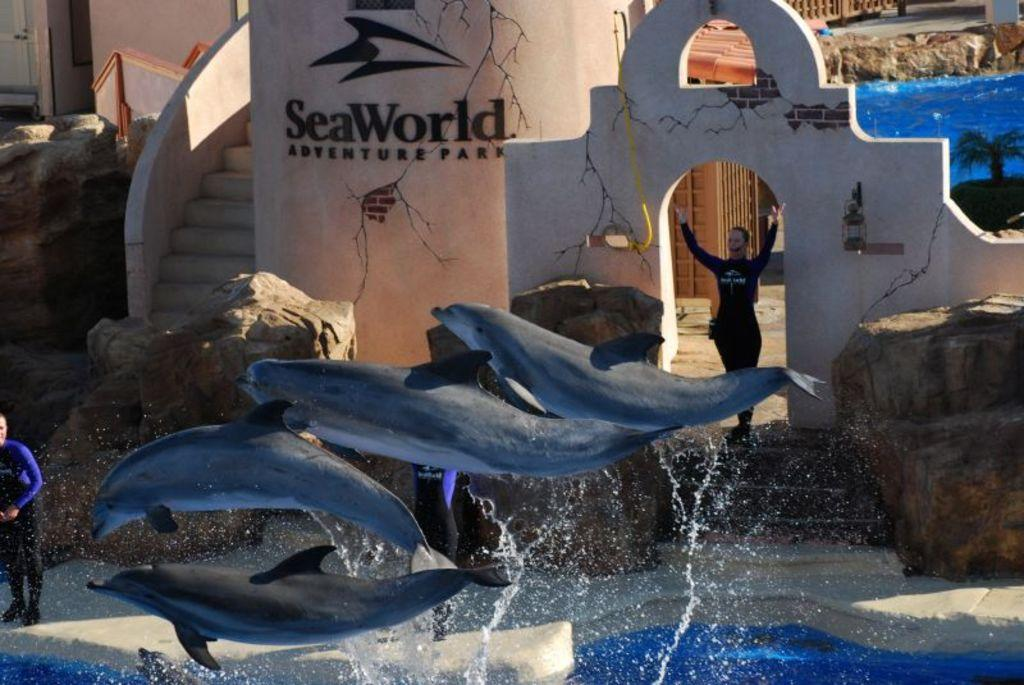What type of animals can be seen in the water in the image? There are fishes in the water in the image. What are the fishes doing in the image? The fishes appear to be flying or jumping in the image. Are there any people present near the water in the image? Yes, there are people standing near the water in the image. What else can be seen in the vicinity of the water? There are rocks and walls or structures near the water in the image. What is the title of the book the fishes are reading in the image? There is no book or reading activity depicted in the image; the fishes are flying or jumping in the water. 